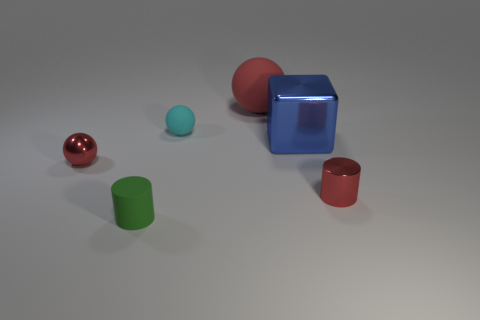Subtract all cyan rubber spheres. How many spheres are left? 2 Add 4 small cyan matte spheres. How many objects exist? 10 Subtract all green cylinders. How many cylinders are left? 1 Subtract 1 blocks. How many blocks are left? 0 Subtract all cylinders. How many objects are left? 4 Subtract all gray cubes. Subtract all gray spheres. How many cubes are left? 1 Subtract all purple blocks. How many red spheres are left? 2 Subtract all small metal things. Subtract all large metal cubes. How many objects are left? 3 Add 2 rubber spheres. How many rubber spheres are left? 4 Add 4 tiny gray rubber balls. How many tiny gray rubber balls exist? 4 